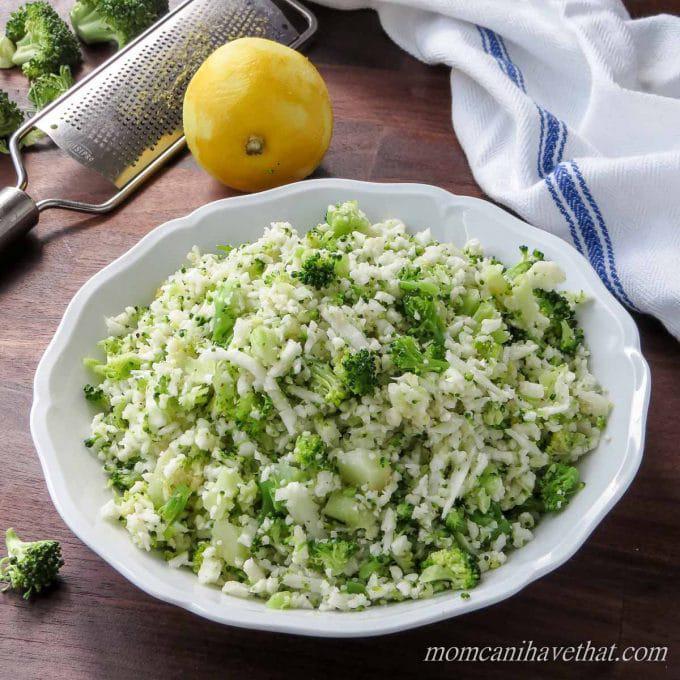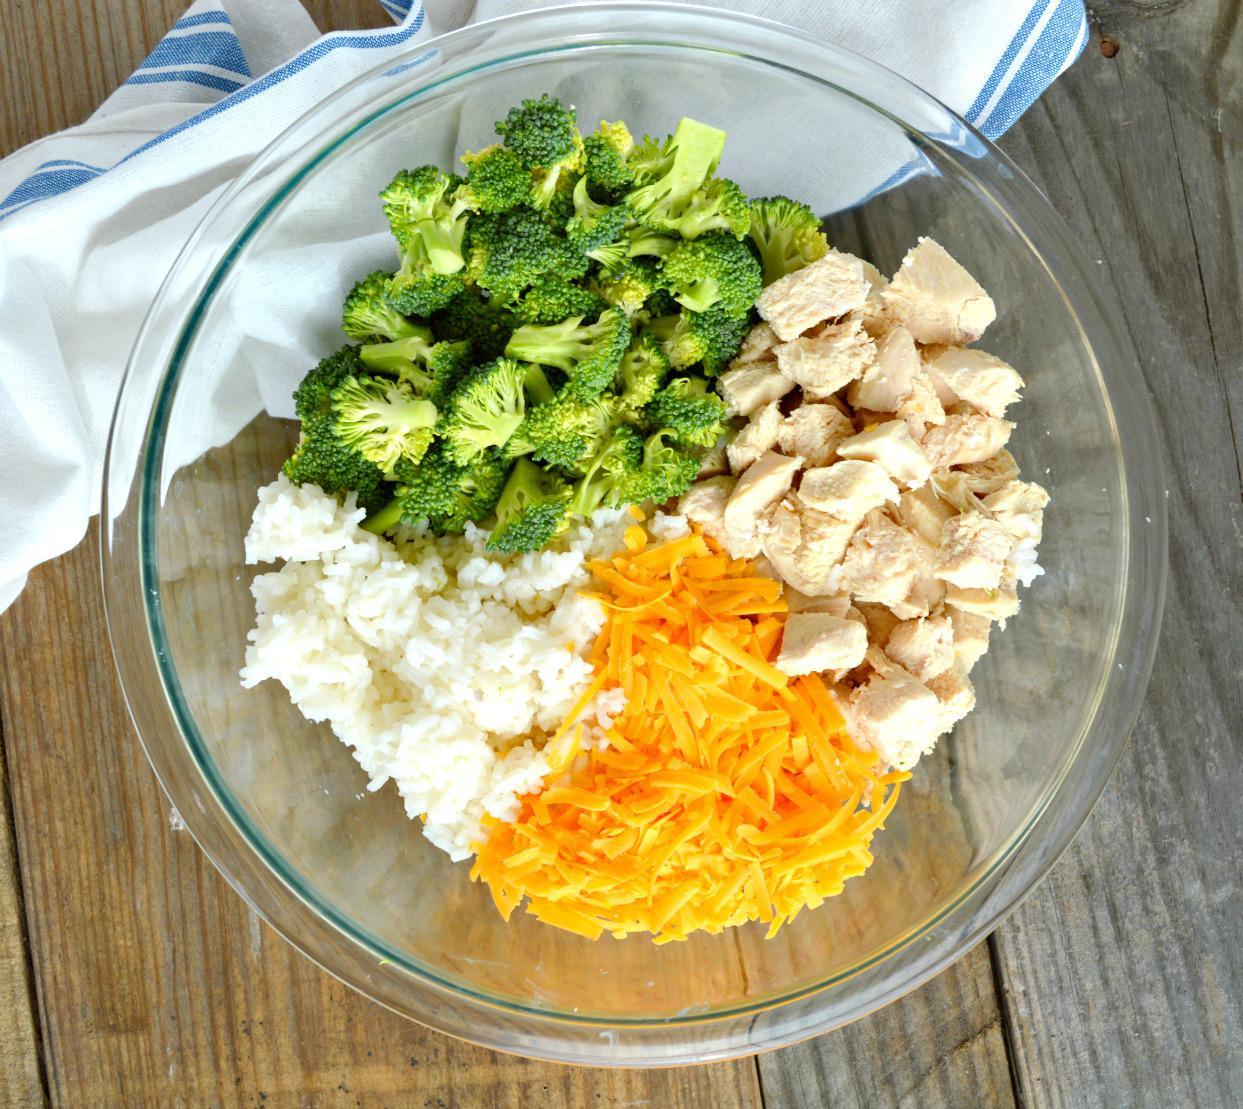The first image is the image on the left, the second image is the image on the right. Evaluate the accuracy of this statement regarding the images: "One image features whole broccoli pieces in a bowl.". Is it true? Answer yes or no. Yes. 